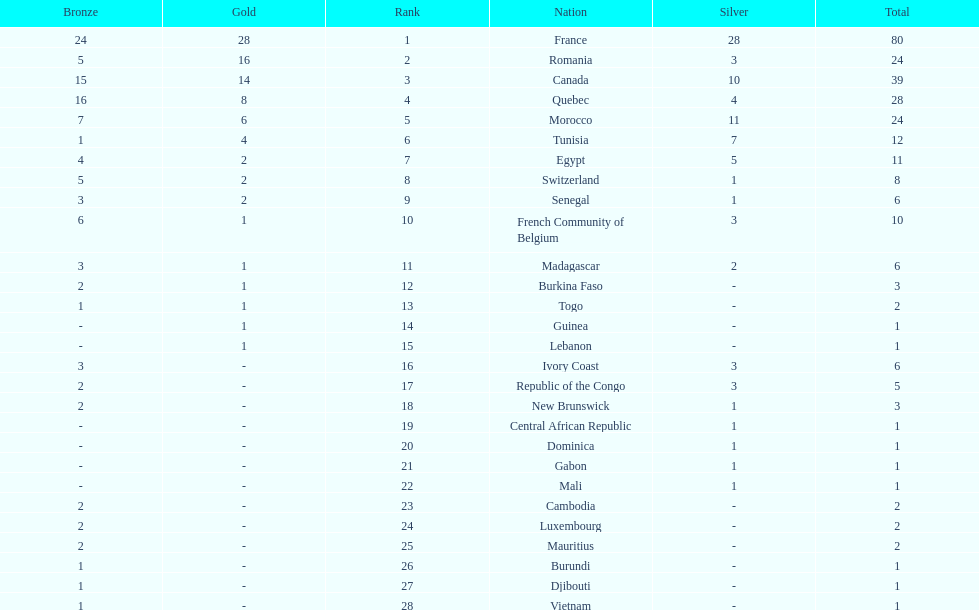How many counties have at least one silver medal? 18. 